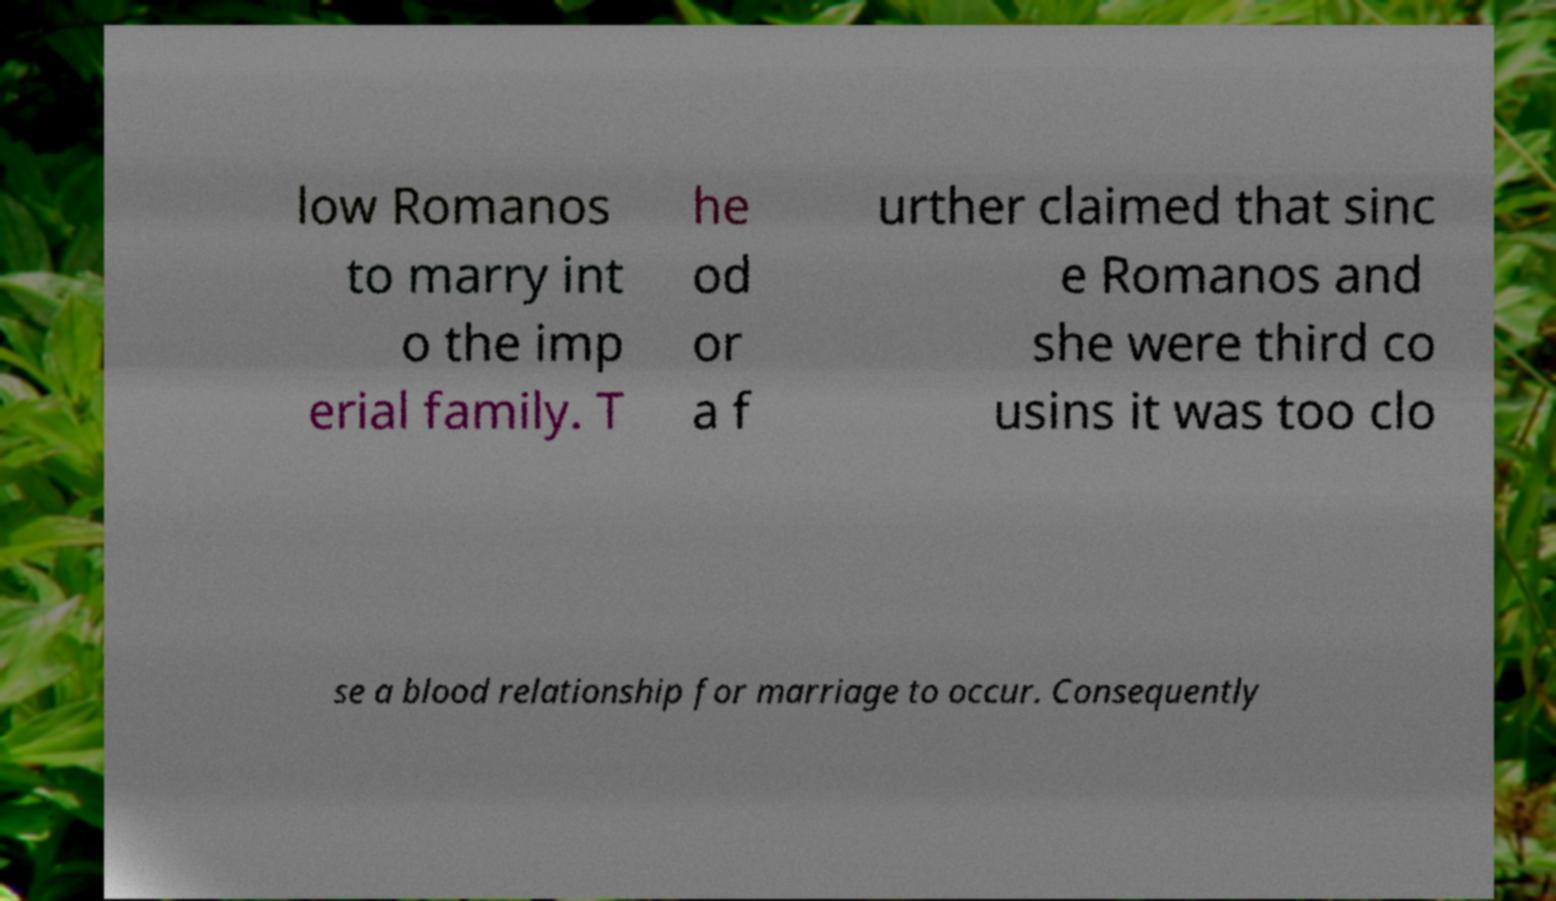Please identify and transcribe the text found in this image. low Romanos to marry int o the imp erial family. T he od or a f urther claimed that sinc e Romanos and she were third co usins it was too clo se a blood relationship for marriage to occur. Consequently 